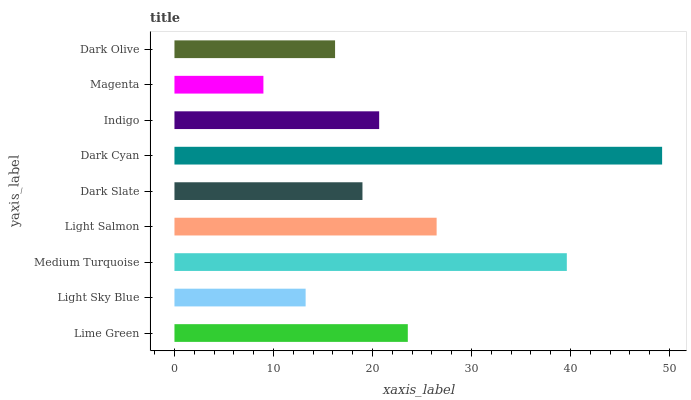Is Magenta the minimum?
Answer yes or no. Yes. Is Dark Cyan the maximum?
Answer yes or no. Yes. Is Light Sky Blue the minimum?
Answer yes or no. No. Is Light Sky Blue the maximum?
Answer yes or no. No. Is Lime Green greater than Light Sky Blue?
Answer yes or no. Yes. Is Light Sky Blue less than Lime Green?
Answer yes or no. Yes. Is Light Sky Blue greater than Lime Green?
Answer yes or no. No. Is Lime Green less than Light Sky Blue?
Answer yes or no. No. Is Indigo the high median?
Answer yes or no. Yes. Is Indigo the low median?
Answer yes or no. Yes. Is Magenta the high median?
Answer yes or no. No. Is Magenta the low median?
Answer yes or no. No. 